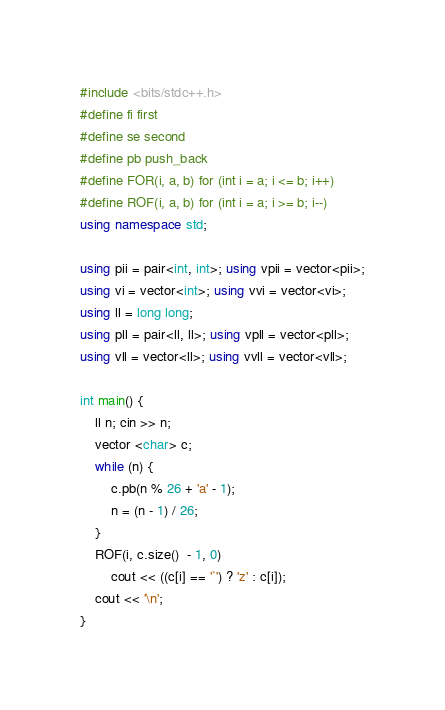Convert code to text. <code><loc_0><loc_0><loc_500><loc_500><_C++_>#include <bits/stdc++.h>
#define fi first
#define se second
#define pb push_back
#define FOR(i, a, b) for (int i = a; i <= b; i++)
#define ROF(i, a, b) for (int i = a; i >= b; i--)
using namespace std;

using pii = pair<int, int>; using vpii = vector<pii>;
using vi = vector<int>; using vvi = vector<vi>;
using ll = long long;
using pll = pair<ll, ll>; using vpll = vector<pll>;
using vll = vector<ll>; using vvll = vector<vll>;

int main() {
    ll n; cin >> n;
    vector <char> c;
    while (n) {
        c.pb(n % 26 + 'a' - 1);
        n = (n - 1) / 26;
    }
    ROF(i, c.size()  - 1, 0)
        cout << ((c[i] == '`') ? 'z' : c[i]);
    cout << '\n';
}</code> 